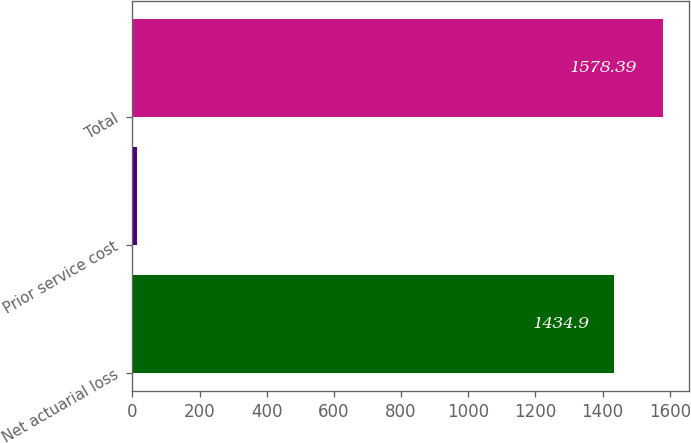Convert chart to OTSL. <chart><loc_0><loc_0><loc_500><loc_500><bar_chart><fcel>Net actuarial loss<fcel>Prior service cost<fcel>Total<nl><fcel>1434.9<fcel>14<fcel>1578.39<nl></chart> 